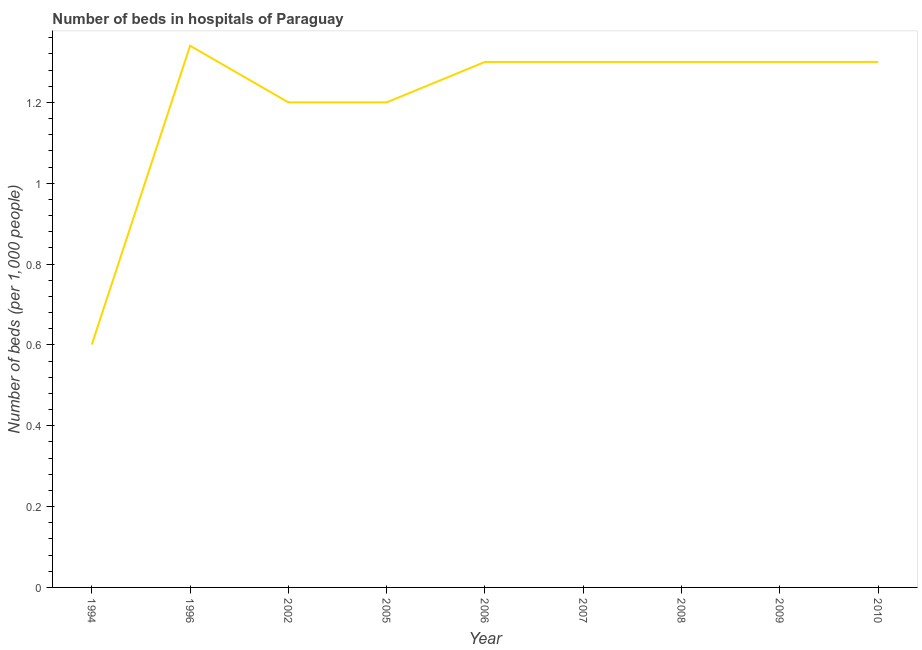Across all years, what is the maximum number of hospital beds?
Your answer should be very brief. 1.34. Across all years, what is the minimum number of hospital beds?
Keep it short and to the point. 0.6. In which year was the number of hospital beds maximum?
Offer a terse response. 1996. In which year was the number of hospital beds minimum?
Offer a terse response. 1994. What is the sum of the number of hospital beds?
Your answer should be compact. 10.84. What is the difference between the number of hospital beds in 2005 and 2006?
Provide a succinct answer. -0.1. What is the average number of hospital beds per year?
Offer a very short reply. 1.2. In how many years, is the number of hospital beds greater than 0.04 %?
Offer a very short reply. 9. Do a majority of the years between 2009 and 2007 (inclusive) have number of hospital beds greater than 0.7600000000000001 %?
Keep it short and to the point. No. What is the ratio of the number of hospital beds in 2002 to that in 2007?
Make the answer very short. 0.92. Is the number of hospital beds in 1994 less than that in 2009?
Your answer should be compact. Yes. Is the difference between the number of hospital beds in 2002 and 2009 greater than the difference between any two years?
Offer a terse response. No. What is the difference between the highest and the second highest number of hospital beds?
Ensure brevity in your answer.  0.04. Is the sum of the number of hospital beds in 1994 and 1996 greater than the maximum number of hospital beds across all years?
Make the answer very short. Yes. What is the difference between the highest and the lowest number of hospital beds?
Make the answer very short. 0.74. In how many years, is the number of hospital beds greater than the average number of hospital beds taken over all years?
Your answer should be compact. 6. How many years are there in the graph?
Give a very brief answer. 9. What is the difference between two consecutive major ticks on the Y-axis?
Keep it short and to the point. 0.2. Are the values on the major ticks of Y-axis written in scientific E-notation?
Provide a short and direct response. No. Does the graph contain grids?
Provide a succinct answer. No. What is the title of the graph?
Provide a short and direct response. Number of beds in hospitals of Paraguay. What is the label or title of the X-axis?
Give a very brief answer. Year. What is the label or title of the Y-axis?
Make the answer very short. Number of beds (per 1,0 people). What is the Number of beds (per 1,000 people) of 1994?
Provide a succinct answer. 0.6. What is the Number of beds (per 1,000 people) in 1996?
Provide a succinct answer. 1.34. What is the Number of beds (per 1,000 people) of 2002?
Your answer should be compact. 1.2. What is the Number of beds (per 1,000 people) in 2010?
Your answer should be compact. 1.3. What is the difference between the Number of beds (per 1,000 people) in 1994 and 1996?
Offer a very short reply. -0.74. What is the difference between the Number of beds (per 1,000 people) in 1994 and 2002?
Make the answer very short. -0.6. What is the difference between the Number of beds (per 1,000 people) in 1994 and 2005?
Your response must be concise. -0.6. What is the difference between the Number of beds (per 1,000 people) in 1994 and 2006?
Ensure brevity in your answer.  -0.7. What is the difference between the Number of beds (per 1,000 people) in 1994 and 2007?
Ensure brevity in your answer.  -0.7. What is the difference between the Number of beds (per 1,000 people) in 1994 and 2008?
Ensure brevity in your answer.  -0.7. What is the difference between the Number of beds (per 1,000 people) in 1994 and 2009?
Your response must be concise. -0.7. What is the difference between the Number of beds (per 1,000 people) in 1994 and 2010?
Offer a terse response. -0.7. What is the difference between the Number of beds (per 1,000 people) in 1996 and 2002?
Your answer should be compact. 0.14. What is the difference between the Number of beds (per 1,000 people) in 1996 and 2005?
Provide a succinct answer. 0.14. What is the difference between the Number of beds (per 1,000 people) in 1996 and 2007?
Keep it short and to the point. 0.04. What is the difference between the Number of beds (per 1,000 people) in 1996 and 2008?
Ensure brevity in your answer.  0.04. What is the difference between the Number of beds (per 1,000 people) in 1996 and 2010?
Your answer should be compact. 0.04. What is the difference between the Number of beds (per 1,000 people) in 2002 and 2006?
Ensure brevity in your answer.  -0.1. What is the difference between the Number of beds (per 1,000 people) in 2002 and 2008?
Your response must be concise. -0.1. What is the difference between the Number of beds (per 1,000 people) in 2002 and 2009?
Give a very brief answer. -0.1. What is the difference between the Number of beds (per 1,000 people) in 2005 and 2006?
Provide a succinct answer. -0.1. What is the difference between the Number of beds (per 1,000 people) in 2005 and 2008?
Offer a terse response. -0.1. What is the difference between the Number of beds (per 1,000 people) in 2006 and 2008?
Your answer should be compact. 0. What is the difference between the Number of beds (per 1,000 people) in 2006 and 2009?
Provide a succinct answer. 0. What is the difference between the Number of beds (per 1,000 people) in 2006 and 2010?
Ensure brevity in your answer.  0. What is the difference between the Number of beds (per 1,000 people) in 2007 and 2009?
Offer a terse response. 0. What is the ratio of the Number of beds (per 1,000 people) in 1994 to that in 1996?
Offer a terse response. 0.45. What is the ratio of the Number of beds (per 1,000 people) in 1994 to that in 2002?
Your answer should be compact. 0.5. What is the ratio of the Number of beds (per 1,000 people) in 1994 to that in 2005?
Ensure brevity in your answer.  0.5. What is the ratio of the Number of beds (per 1,000 people) in 1994 to that in 2006?
Give a very brief answer. 0.46. What is the ratio of the Number of beds (per 1,000 people) in 1994 to that in 2007?
Make the answer very short. 0.46. What is the ratio of the Number of beds (per 1,000 people) in 1994 to that in 2008?
Keep it short and to the point. 0.46. What is the ratio of the Number of beds (per 1,000 people) in 1994 to that in 2009?
Your response must be concise. 0.46. What is the ratio of the Number of beds (per 1,000 people) in 1994 to that in 2010?
Your answer should be very brief. 0.46. What is the ratio of the Number of beds (per 1,000 people) in 1996 to that in 2002?
Ensure brevity in your answer.  1.12. What is the ratio of the Number of beds (per 1,000 people) in 1996 to that in 2005?
Keep it short and to the point. 1.12. What is the ratio of the Number of beds (per 1,000 people) in 1996 to that in 2006?
Your answer should be very brief. 1.03. What is the ratio of the Number of beds (per 1,000 people) in 1996 to that in 2007?
Keep it short and to the point. 1.03. What is the ratio of the Number of beds (per 1,000 people) in 1996 to that in 2008?
Provide a succinct answer. 1.03. What is the ratio of the Number of beds (per 1,000 people) in 1996 to that in 2009?
Your response must be concise. 1.03. What is the ratio of the Number of beds (per 1,000 people) in 1996 to that in 2010?
Make the answer very short. 1.03. What is the ratio of the Number of beds (per 1,000 people) in 2002 to that in 2006?
Keep it short and to the point. 0.92. What is the ratio of the Number of beds (per 1,000 people) in 2002 to that in 2007?
Provide a succinct answer. 0.92. What is the ratio of the Number of beds (per 1,000 people) in 2002 to that in 2008?
Your answer should be very brief. 0.92. What is the ratio of the Number of beds (per 1,000 people) in 2002 to that in 2009?
Provide a short and direct response. 0.92. What is the ratio of the Number of beds (per 1,000 people) in 2002 to that in 2010?
Your response must be concise. 0.92. What is the ratio of the Number of beds (per 1,000 people) in 2005 to that in 2006?
Provide a short and direct response. 0.92. What is the ratio of the Number of beds (per 1,000 people) in 2005 to that in 2007?
Offer a terse response. 0.92. What is the ratio of the Number of beds (per 1,000 people) in 2005 to that in 2008?
Make the answer very short. 0.92. What is the ratio of the Number of beds (per 1,000 people) in 2005 to that in 2009?
Your response must be concise. 0.92. What is the ratio of the Number of beds (per 1,000 people) in 2005 to that in 2010?
Your answer should be very brief. 0.92. What is the ratio of the Number of beds (per 1,000 people) in 2006 to that in 2008?
Offer a very short reply. 1. What is the ratio of the Number of beds (per 1,000 people) in 2006 to that in 2009?
Offer a very short reply. 1. What is the ratio of the Number of beds (per 1,000 people) in 2007 to that in 2008?
Your answer should be very brief. 1. What is the ratio of the Number of beds (per 1,000 people) in 2007 to that in 2010?
Keep it short and to the point. 1. 